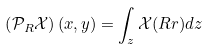Convert formula to latex. <formula><loc_0><loc_0><loc_500><loc_500>\left ( \mathcal { P } _ { R } \mathcal { X } \right ) ( x , y ) = \int _ { z } \mathcal { X } ( R r ) d z</formula> 